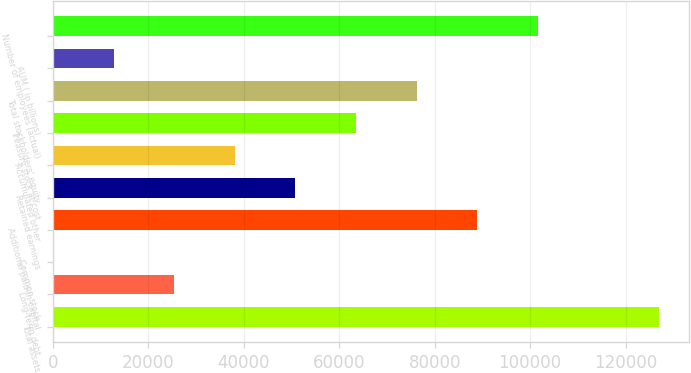Convert chart. <chart><loc_0><loc_0><loc_500><loc_500><bar_chart><fcel>Total assets<fcel>Long-term debt<fcel>Common stock<fcel>Additional paid-in capital<fcel>Retained earnings<fcel>Accumulated other<fcel>Treasury stock at cost<fcel>Total stockholders' equity<fcel>AUM ( in billions)<fcel>Number of employees (actual)<nl><fcel>127035<fcel>25410.1<fcel>3.8<fcel>88925.9<fcel>50816.4<fcel>38113.3<fcel>63519.6<fcel>76222.8<fcel>12707<fcel>101629<nl></chart> 